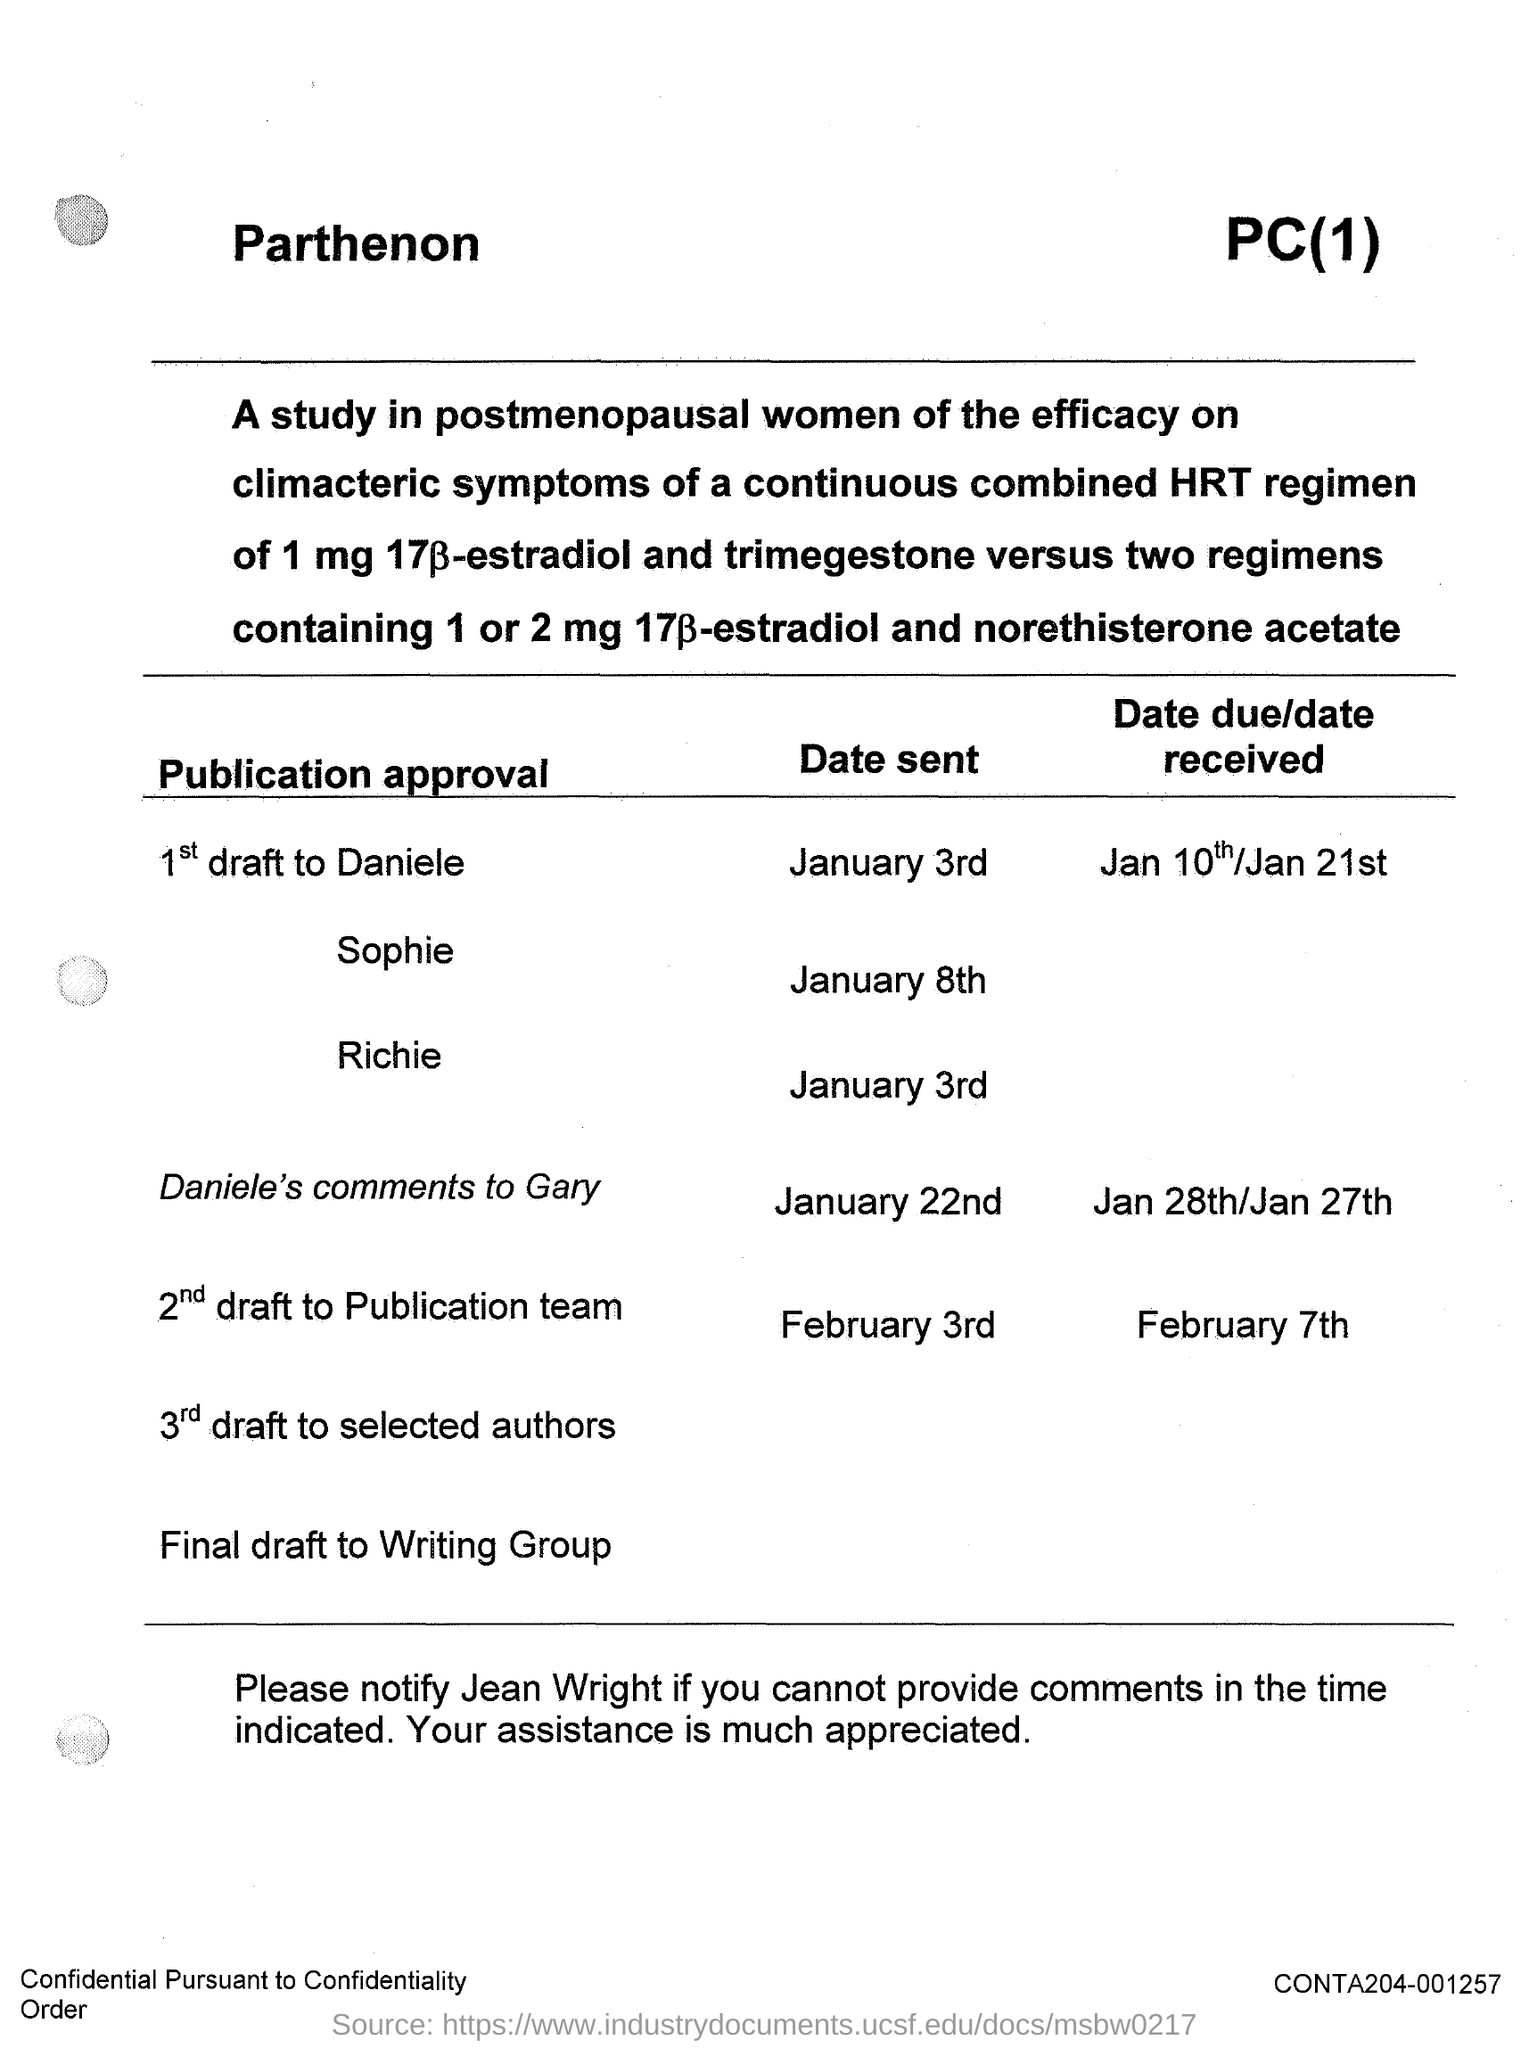Specify some key components in this picture. The date mentioned in the conversation between Richie and the other person is January 3rd. The date mentioned in the text is January 8th. The first draft of the message was sent on January 3rd. 